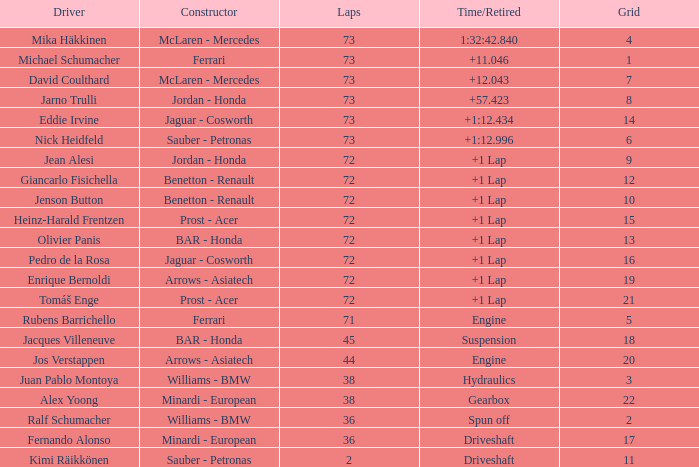Who is the maker when the laps exceed 72 and the driver is eddie irvine? Jaguar - Cosworth. 